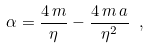Convert formula to latex. <formula><loc_0><loc_0><loc_500><loc_500>\alpha = \frac { 4 \, m } { \eta } - \frac { 4 \, m \, a } { \eta ^ { 2 } } \ ,</formula> 